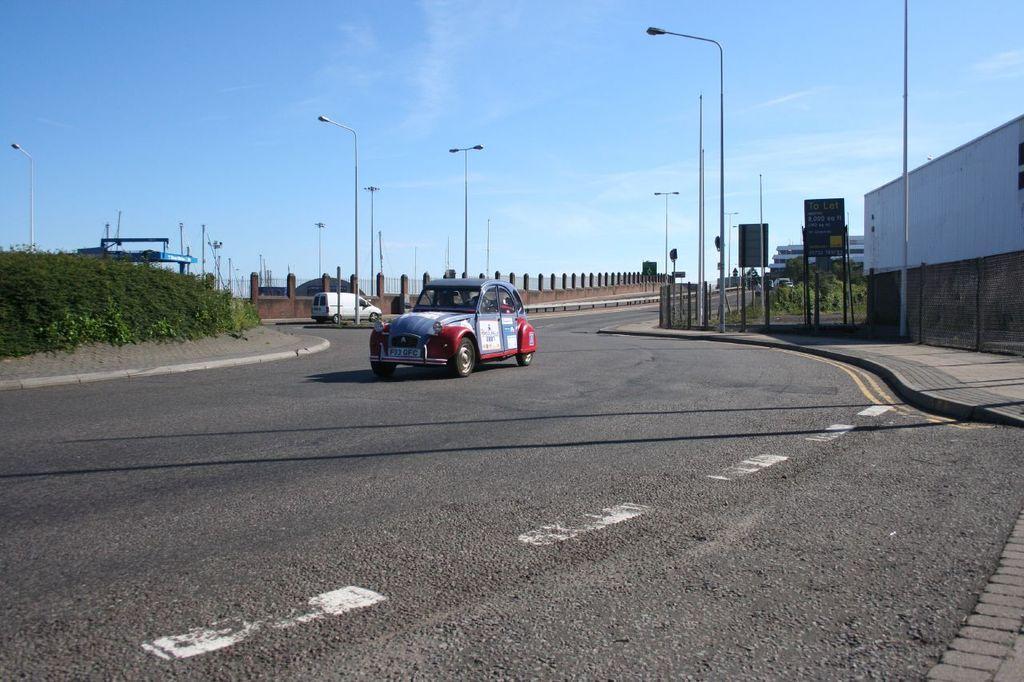Can you describe this image briefly? In this image, we can see two vehicles, road, plants, poles, sign boards, boards, pillars and walkway. Background there is a sky. 